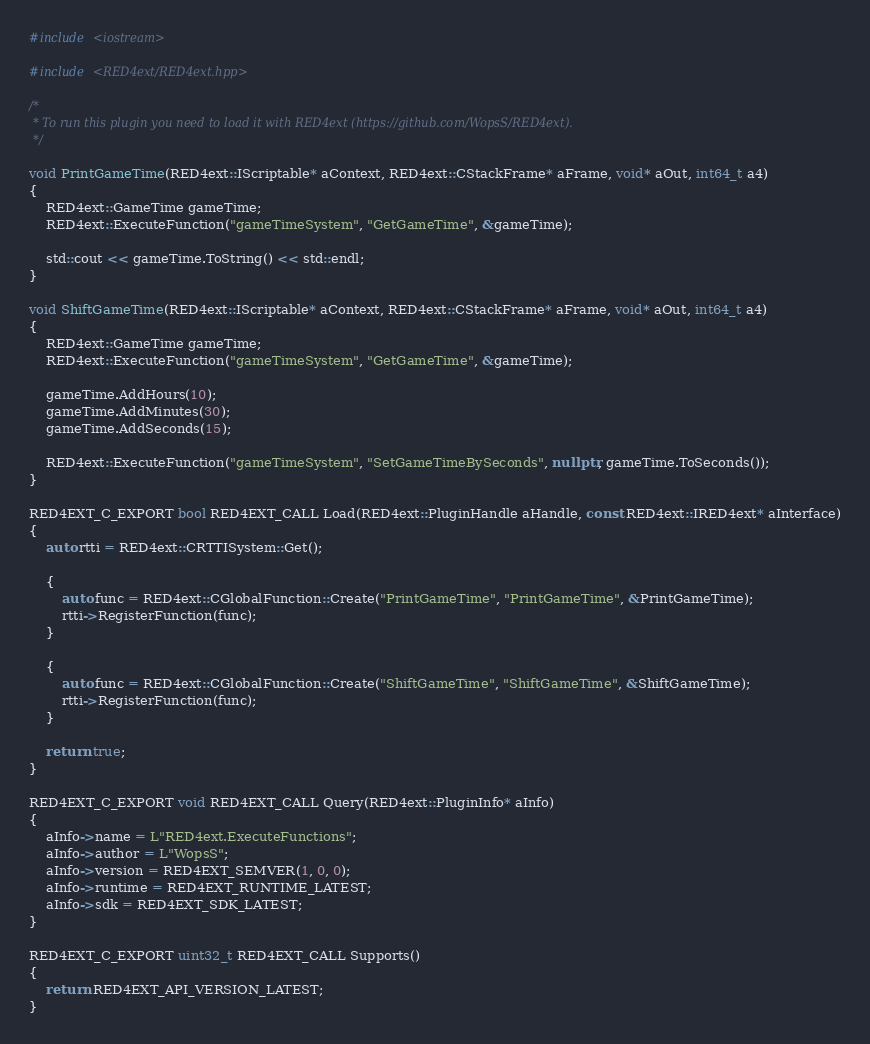Convert code to text. <code><loc_0><loc_0><loc_500><loc_500><_C++_>#include <iostream>

#include <RED4ext/RED4ext.hpp>

/*
 * To run this plugin you need to load it with RED4ext (https://github.com/WopsS/RED4ext).
 */

void PrintGameTime(RED4ext::IScriptable* aContext, RED4ext::CStackFrame* aFrame, void* aOut, int64_t a4)
{
    RED4ext::GameTime gameTime;
    RED4ext::ExecuteFunction("gameTimeSystem", "GetGameTime", &gameTime);

    std::cout << gameTime.ToString() << std::endl;
}

void ShiftGameTime(RED4ext::IScriptable* aContext, RED4ext::CStackFrame* aFrame, void* aOut, int64_t a4)
{
    RED4ext::GameTime gameTime;
    RED4ext::ExecuteFunction("gameTimeSystem", "GetGameTime", &gameTime);

    gameTime.AddHours(10);
    gameTime.AddMinutes(30);
    gameTime.AddSeconds(15);

    RED4ext::ExecuteFunction("gameTimeSystem", "SetGameTimeBySeconds", nullptr, gameTime.ToSeconds());
}

RED4EXT_C_EXPORT bool RED4EXT_CALL Load(RED4ext::PluginHandle aHandle, const RED4ext::IRED4ext* aInterface)
{
    auto rtti = RED4ext::CRTTISystem::Get();

    {
        auto func = RED4ext::CGlobalFunction::Create("PrintGameTime", "PrintGameTime", &PrintGameTime);
        rtti->RegisterFunction(func);
    }

    {
        auto func = RED4ext::CGlobalFunction::Create("ShiftGameTime", "ShiftGameTime", &ShiftGameTime);
        rtti->RegisterFunction(func);
    }

    return true;
}

RED4EXT_C_EXPORT void RED4EXT_CALL Query(RED4ext::PluginInfo* aInfo)
{
    aInfo->name = L"RED4ext.ExecuteFunctions";
    aInfo->author = L"WopsS";
    aInfo->version = RED4EXT_SEMVER(1, 0, 0);
    aInfo->runtime = RED4EXT_RUNTIME_LATEST;
    aInfo->sdk = RED4EXT_SDK_LATEST;
}

RED4EXT_C_EXPORT uint32_t RED4EXT_CALL Supports()
{
    return RED4EXT_API_VERSION_LATEST;
}
</code> 